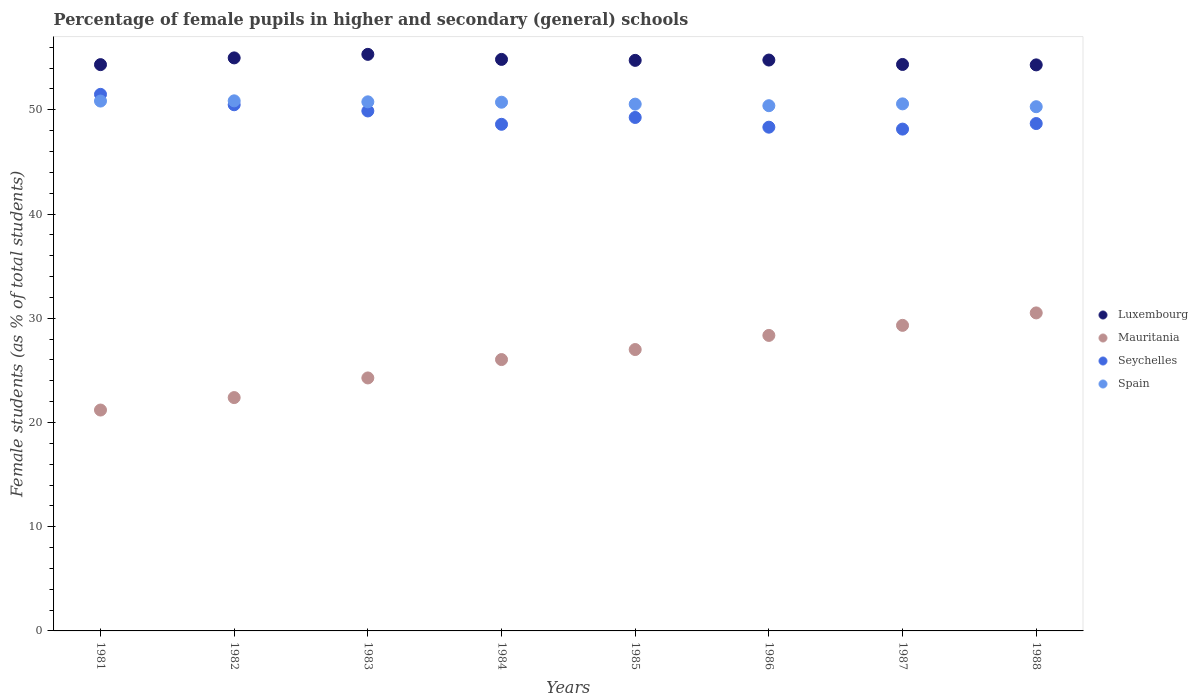What is the percentage of female pupils in higher and secondary schools in Luxembourg in 1983?
Your response must be concise. 55.32. Across all years, what is the maximum percentage of female pupils in higher and secondary schools in Luxembourg?
Provide a short and direct response. 55.32. Across all years, what is the minimum percentage of female pupils in higher and secondary schools in Mauritania?
Provide a succinct answer. 21.19. In which year was the percentage of female pupils in higher and secondary schools in Spain maximum?
Your response must be concise. 1982. In which year was the percentage of female pupils in higher and secondary schools in Mauritania minimum?
Give a very brief answer. 1981. What is the total percentage of female pupils in higher and secondary schools in Mauritania in the graph?
Keep it short and to the point. 209.07. What is the difference between the percentage of female pupils in higher and secondary schools in Luxembourg in 1983 and that in 1984?
Make the answer very short. 0.48. What is the difference between the percentage of female pupils in higher and secondary schools in Luxembourg in 1988 and the percentage of female pupils in higher and secondary schools in Seychelles in 1986?
Keep it short and to the point. 5.98. What is the average percentage of female pupils in higher and secondary schools in Mauritania per year?
Offer a terse response. 26.13. In the year 1987, what is the difference between the percentage of female pupils in higher and secondary schools in Spain and percentage of female pupils in higher and secondary schools in Seychelles?
Ensure brevity in your answer.  2.42. What is the ratio of the percentage of female pupils in higher and secondary schools in Mauritania in 1984 to that in 1987?
Ensure brevity in your answer.  0.89. What is the difference between the highest and the second highest percentage of female pupils in higher and secondary schools in Luxembourg?
Your response must be concise. 0.34. What is the difference between the highest and the lowest percentage of female pupils in higher and secondary schools in Seychelles?
Offer a terse response. 3.33. In how many years, is the percentage of female pupils in higher and secondary schools in Seychelles greater than the average percentage of female pupils in higher and secondary schools in Seychelles taken over all years?
Provide a succinct answer. 3. Is it the case that in every year, the sum of the percentage of female pupils in higher and secondary schools in Spain and percentage of female pupils in higher and secondary schools in Mauritania  is greater than the percentage of female pupils in higher and secondary schools in Luxembourg?
Offer a very short reply. Yes. Does the graph contain grids?
Offer a terse response. No. How many legend labels are there?
Offer a terse response. 4. What is the title of the graph?
Your response must be concise. Percentage of female pupils in higher and secondary (general) schools. Does "Malta" appear as one of the legend labels in the graph?
Make the answer very short. No. What is the label or title of the X-axis?
Make the answer very short. Years. What is the label or title of the Y-axis?
Offer a terse response. Female students (as % of total students). What is the Female students (as % of total students) in Luxembourg in 1981?
Keep it short and to the point. 54.33. What is the Female students (as % of total students) of Mauritania in 1981?
Make the answer very short. 21.19. What is the Female students (as % of total students) in Seychelles in 1981?
Provide a short and direct response. 51.48. What is the Female students (as % of total students) of Spain in 1981?
Offer a terse response. 50.84. What is the Female students (as % of total students) in Luxembourg in 1982?
Make the answer very short. 54.98. What is the Female students (as % of total students) in Mauritania in 1982?
Provide a succinct answer. 22.39. What is the Female students (as % of total students) of Seychelles in 1982?
Make the answer very short. 50.48. What is the Female students (as % of total students) of Spain in 1982?
Offer a very short reply. 50.86. What is the Female students (as % of total students) of Luxembourg in 1983?
Make the answer very short. 55.32. What is the Female students (as % of total students) in Mauritania in 1983?
Provide a short and direct response. 24.27. What is the Female students (as % of total students) in Seychelles in 1983?
Provide a short and direct response. 49.89. What is the Female students (as % of total students) in Spain in 1983?
Provide a short and direct response. 50.76. What is the Female students (as % of total students) in Luxembourg in 1984?
Keep it short and to the point. 54.83. What is the Female students (as % of total students) in Mauritania in 1984?
Offer a very short reply. 26.03. What is the Female students (as % of total students) of Seychelles in 1984?
Provide a succinct answer. 48.61. What is the Female students (as % of total students) of Spain in 1984?
Provide a short and direct response. 50.73. What is the Female students (as % of total students) of Luxembourg in 1985?
Provide a short and direct response. 54.74. What is the Female students (as % of total students) of Mauritania in 1985?
Provide a succinct answer. 27. What is the Female students (as % of total students) of Seychelles in 1985?
Your response must be concise. 49.26. What is the Female students (as % of total students) in Spain in 1985?
Make the answer very short. 50.54. What is the Female students (as % of total students) of Luxembourg in 1986?
Offer a very short reply. 54.77. What is the Female students (as % of total students) in Mauritania in 1986?
Make the answer very short. 28.35. What is the Female students (as % of total students) of Seychelles in 1986?
Your answer should be very brief. 48.33. What is the Female students (as % of total students) in Spain in 1986?
Offer a very short reply. 50.39. What is the Female students (as % of total students) of Luxembourg in 1987?
Your answer should be very brief. 54.35. What is the Female students (as % of total students) in Mauritania in 1987?
Your answer should be very brief. 29.32. What is the Female students (as % of total students) of Seychelles in 1987?
Offer a terse response. 48.15. What is the Female students (as % of total students) in Spain in 1987?
Make the answer very short. 50.57. What is the Female students (as % of total students) in Luxembourg in 1988?
Make the answer very short. 54.31. What is the Female students (as % of total students) in Mauritania in 1988?
Give a very brief answer. 30.51. What is the Female students (as % of total students) in Seychelles in 1988?
Provide a succinct answer. 48.68. What is the Female students (as % of total students) of Spain in 1988?
Make the answer very short. 50.29. Across all years, what is the maximum Female students (as % of total students) of Luxembourg?
Provide a short and direct response. 55.32. Across all years, what is the maximum Female students (as % of total students) in Mauritania?
Your answer should be very brief. 30.51. Across all years, what is the maximum Female students (as % of total students) of Seychelles?
Provide a succinct answer. 51.48. Across all years, what is the maximum Female students (as % of total students) in Spain?
Your response must be concise. 50.86. Across all years, what is the minimum Female students (as % of total students) of Luxembourg?
Your answer should be compact. 54.31. Across all years, what is the minimum Female students (as % of total students) of Mauritania?
Ensure brevity in your answer.  21.19. Across all years, what is the minimum Female students (as % of total students) in Seychelles?
Offer a very short reply. 48.15. Across all years, what is the minimum Female students (as % of total students) in Spain?
Ensure brevity in your answer.  50.29. What is the total Female students (as % of total students) in Luxembourg in the graph?
Make the answer very short. 437.63. What is the total Female students (as % of total students) of Mauritania in the graph?
Give a very brief answer. 209.07. What is the total Female students (as % of total students) in Seychelles in the graph?
Offer a very short reply. 394.88. What is the total Female students (as % of total students) in Spain in the graph?
Offer a terse response. 404.98. What is the difference between the Female students (as % of total students) in Luxembourg in 1981 and that in 1982?
Make the answer very short. -0.65. What is the difference between the Female students (as % of total students) in Mauritania in 1981 and that in 1982?
Offer a very short reply. -1.2. What is the difference between the Female students (as % of total students) of Seychelles in 1981 and that in 1982?
Provide a succinct answer. 1. What is the difference between the Female students (as % of total students) in Spain in 1981 and that in 1982?
Your response must be concise. -0.02. What is the difference between the Female students (as % of total students) in Luxembourg in 1981 and that in 1983?
Your response must be concise. -0.99. What is the difference between the Female students (as % of total students) of Mauritania in 1981 and that in 1983?
Give a very brief answer. -3.08. What is the difference between the Female students (as % of total students) in Seychelles in 1981 and that in 1983?
Offer a terse response. 1.59. What is the difference between the Female students (as % of total students) of Spain in 1981 and that in 1983?
Your response must be concise. 0.07. What is the difference between the Female students (as % of total students) of Luxembourg in 1981 and that in 1984?
Keep it short and to the point. -0.5. What is the difference between the Female students (as % of total students) in Mauritania in 1981 and that in 1984?
Offer a very short reply. -4.84. What is the difference between the Female students (as % of total students) of Seychelles in 1981 and that in 1984?
Offer a very short reply. 2.87. What is the difference between the Female students (as % of total students) in Spain in 1981 and that in 1984?
Offer a terse response. 0.11. What is the difference between the Female students (as % of total students) in Luxembourg in 1981 and that in 1985?
Your response must be concise. -0.41. What is the difference between the Female students (as % of total students) in Mauritania in 1981 and that in 1985?
Your answer should be compact. -5.81. What is the difference between the Female students (as % of total students) of Seychelles in 1981 and that in 1985?
Your response must be concise. 2.22. What is the difference between the Female students (as % of total students) of Spain in 1981 and that in 1985?
Keep it short and to the point. 0.29. What is the difference between the Female students (as % of total students) of Luxembourg in 1981 and that in 1986?
Give a very brief answer. -0.44. What is the difference between the Female students (as % of total students) of Mauritania in 1981 and that in 1986?
Make the answer very short. -7.16. What is the difference between the Female students (as % of total students) in Seychelles in 1981 and that in 1986?
Your answer should be compact. 3.15. What is the difference between the Female students (as % of total students) of Spain in 1981 and that in 1986?
Provide a short and direct response. 0.44. What is the difference between the Female students (as % of total students) in Luxembourg in 1981 and that in 1987?
Give a very brief answer. -0.02. What is the difference between the Female students (as % of total students) in Mauritania in 1981 and that in 1987?
Ensure brevity in your answer.  -8.13. What is the difference between the Female students (as % of total students) in Seychelles in 1981 and that in 1987?
Provide a short and direct response. 3.33. What is the difference between the Female students (as % of total students) in Spain in 1981 and that in 1987?
Provide a succinct answer. 0.27. What is the difference between the Female students (as % of total students) of Luxembourg in 1981 and that in 1988?
Offer a very short reply. 0.02. What is the difference between the Female students (as % of total students) of Mauritania in 1981 and that in 1988?
Give a very brief answer. -9.32. What is the difference between the Female students (as % of total students) in Seychelles in 1981 and that in 1988?
Your response must be concise. 2.8. What is the difference between the Female students (as % of total students) in Spain in 1981 and that in 1988?
Provide a short and direct response. 0.54. What is the difference between the Female students (as % of total students) of Luxembourg in 1982 and that in 1983?
Make the answer very short. -0.34. What is the difference between the Female students (as % of total students) in Mauritania in 1982 and that in 1983?
Ensure brevity in your answer.  -1.88. What is the difference between the Female students (as % of total students) of Seychelles in 1982 and that in 1983?
Make the answer very short. 0.59. What is the difference between the Female students (as % of total students) in Spain in 1982 and that in 1983?
Ensure brevity in your answer.  0.1. What is the difference between the Female students (as % of total students) of Luxembourg in 1982 and that in 1984?
Ensure brevity in your answer.  0.14. What is the difference between the Female students (as % of total students) of Mauritania in 1982 and that in 1984?
Ensure brevity in your answer.  -3.65. What is the difference between the Female students (as % of total students) of Seychelles in 1982 and that in 1984?
Provide a short and direct response. 1.88. What is the difference between the Female students (as % of total students) of Spain in 1982 and that in 1984?
Ensure brevity in your answer.  0.13. What is the difference between the Female students (as % of total students) in Luxembourg in 1982 and that in 1985?
Offer a terse response. 0.24. What is the difference between the Female students (as % of total students) of Mauritania in 1982 and that in 1985?
Provide a short and direct response. -4.61. What is the difference between the Female students (as % of total students) of Seychelles in 1982 and that in 1985?
Keep it short and to the point. 1.22. What is the difference between the Female students (as % of total students) in Spain in 1982 and that in 1985?
Provide a succinct answer. 0.32. What is the difference between the Female students (as % of total students) in Luxembourg in 1982 and that in 1986?
Your response must be concise. 0.2. What is the difference between the Female students (as % of total students) of Mauritania in 1982 and that in 1986?
Offer a very short reply. -5.96. What is the difference between the Female students (as % of total students) in Seychelles in 1982 and that in 1986?
Provide a succinct answer. 2.15. What is the difference between the Female students (as % of total students) of Spain in 1982 and that in 1986?
Ensure brevity in your answer.  0.47. What is the difference between the Female students (as % of total students) in Luxembourg in 1982 and that in 1987?
Your response must be concise. 0.63. What is the difference between the Female students (as % of total students) in Mauritania in 1982 and that in 1987?
Make the answer very short. -6.93. What is the difference between the Female students (as % of total students) of Seychelles in 1982 and that in 1987?
Your answer should be compact. 2.34. What is the difference between the Female students (as % of total students) of Spain in 1982 and that in 1987?
Give a very brief answer. 0.29. What is the difference between the Female students (as % of total students) in Luxembourg in 1982 and that in 1988?
Make the answer very short. 0.67. What is the difference between the Female students (as % of total students) of Mauritania in 1982 and that in 1988?
Make the answer very short. -8.12. What is the difference between the Female students (as % of total students) in Seychelles in 1982 and that in 1988?
Ensure brevity in your answer.  1.8. What is the difference between the Female students (as % of total students) of Spain in 1982 and that in 1988?
Offer a very short reply. 0.56. What is the difference between the Female students (as % of total students) of Luxembourg in 1983 and that in 1984?
Make the answer very short. 0.48. What is the difference between the Female students (as % of total students) in Mauritania in 1983 and that in 1984?
Offer a very short reply. -1.76. What is the difference between the Female students (as % of total students) in Seychelles in 1983 and that in 1984?
Your answer should be very brief. 1.28. What is the difference between the Female students (as % of total students) of Spain in 1983 and that in 1984?
Your response must be concise. 0.04. What is the difference between the Female students (as % of total students) in Luxembourg in 1983 and that in 1985?
Your response must be concise. 0.58. What is the difference between the Female students (as % of total students) of Mauritania in 1983 and that in 1985?
Give a very brief answer. -2.73. What is the difference between the Female students (as % of total students) in Seychelles in 1983 and that in 1985?
Ensure brevity in your answer.  0.62. What is the difference between the Female students (as % of total students) in Spain in 1983 and that in 1985?
Provide a short and direct response. 0.22. What is the difference between the Female students (as % of total students) of Luxembourg in 1983 and that in 1986?
Provide a succinct answer. 0.55. What is the difference between the Female students (as % of total students) of Mauritania in 1983 and that in 1986?
Your answer should be compact. -4.08. What is the difference between the Female students (as % of total students) of Seychelles in 1983 and that in 1986?
Your answer should be compact. 1.56. What is the difference between the Female students (as % of total students) in Spain in 1983 and that in 1986?
Offer a very short reply. 0.37. What is the difference between the Female students (as % of total students) in Mauritania in 1983 and that in 1987?
Your response must be concise. -5.05. What is the difference between the Female students (as % of total students) in Seychelles in 1983 and that in 1987?
Your answer should be very brief. 1.74. What is the difference between the Female students (as % of total students) of Spain in 1983 and that in 1987?
Provide a succinct answer. 0.19. What is the difference between the Female students (as % of total students) in Luxembourg in 1983 and that in 1988?
Provide a short and direct response. 1.01. What is the difference between the Female students (as % of total students) of Mauritania in 1983 and that in 1988?
Keep it short and to the point. -6.24. What is the difference between the Female students (as % of total students) of Seychelles in 1983 and that in 1988?
Your response must be concise. 1.21. What is the difference between the Female students (as % of total students) in Spain in 1983 and that in 1988?
Your answer should be compact. 0.47. What is the difference between the Female students (as % of total students) of Luxembourg in 1984 and that in 1985?
Your answer should be very brief. 0.09. What is the difference between the Female students (as % of total students) in Mauritania in 1984 and that in 1985?
Keep it short and to the point. -0.96. What is the difference between the Female students (as % of total students) in Seychelles in 1984 and that in 1985?
Keep it short and to the point. -0.66. What is the difference between the Female students (as % of total students) in Spain in 1984 and that in 1985?
Offer a terse response. 0.18. What is the difference between the Female students (as % of total students) of Luxembourg in 1984 and that in 1986?
Provide a succinct answer. 0.06. What is the difference between the Female students (as % of total students) in Mauritania in 1984 and that in 1986?
Your answer should be very brief. -2.32. What is the difference between the Female students (as % of total students) of Seychelles in 1984 and that in 1986?
Your answer should be very brief. 0.28. What is the difference between the Female students (as % of total students) of Spain in 1984 and that in 1986?
Make the answer very short. 0.34. What is the difference between the Female students (as % of total students) of Luxembourg in 1984 and that in 1987?
Your answer should be very brief. 0.49. What is the difference between the Female students (as % of total students) in Mauritania in 1984 and that in 1987?
Offer a very short reply. -3.28. What is the difference between the Female students (as % of total students) of Seychelles in 1984 and that in 1987?
Make the answer very short. 0.46. What is the difference between the Female students (as % of total students) of Spain in 1984 and that in 1987?
Provide a short and direct response. 0.16. What is the difference between the Female students (as % of total students) of Luxembourg in 1984 and that in 1988?
Ensure brevity in your answer.  0.53. What is the difference between the Female students (as % of total students) of Mauritania in 1984 and that in 1988?
Provide a short and direct response. -4.48. What is the difference between the Female students (as % of total students) in Seychelles in 1984 and that in 1988?
Provide a short and direct response. -0.07. What is the difference between the Female students (as % of total students) in Spain in 1984 and that in 1988?
Your response must be concise. 0.43. What is the difference between the Female students (as % of total students) in Luxembourg in 1985 and that in 1986?
Provide a short and direct response. -0.03. What is the difference between the Female students (as % of total students) in Mauritania in 1985 and that in 1986?
Keep it short and to the point. -1.35. What is the difference between the Female students (as % of total students) in Seychelles in 1985 and that in 1986?
Provide a succinct answer. 0.93. What is the difference between the Female students (as % of total students) in Spain in 1985 and that in 1986?
Ensure brevity in your answer.  0.15. What is the difference between the Female students (as % of total students) of Luxembourg in 1985 and that in 1987?
Ensure brevity in your answer.  0.39. What is the difference between the Female students (as % of total students) of Mauritania in 1985 and that in 1987?
Keep it short and to the point. -2.32. What is the difference between the Female students (as % of total students) in Seychelles in 1985 and that in 1987?
Offer a very short reply. 1.12. What is the difference between the Female students (as % of total students) in Spain in 1985 and that in 1987?
Offer a very short reply. -0.03. What is the difference between the Female students (as % of total students) in Luxembourg in 1985 and that in 1988?
Provide a short and direct response. 0.43. What is the difference between the Female students (as % of total students) of Mauritania in 1985 and that in 1988?
Your answer should be compact. -3.51. What is the difference between the Female students (as % of total students) of Seychelles in 1985 and that in 1988?
Provide a succinct answer. 0.58. What is the difference between the Female students (as % of total students) in Spain in 1985 and that in 1988?
Ensure brevity in your answer.  0.25. What is the difference between the Female students (as % of total students) in Luxembourg in 1986 and that in 1987?
Your answer should be very brief. 0.42. What is the difference between the Female students (as % of total students) in Mauritania in 1986 and that in 1987?
Provide a succinct answer. -0.97. What is the difference between the Female students (as % of total students) in Seychelles in 1986 and that in 1987?
Provide a succinct answer. 0.18. What is the difference between the Female students (as % of total students) in Spain in 1986 and that in 1987?
Your response must be concise. -0.18. What is the difference between the Female students (as % of total students) of Luxembourg in 1986 and that in 1988?
Offer a terse response. 0.46. What is the difference between the Female students (as % of total students) in Mauritania in 1986 and that in 1988?
Your response must be concise. -2.16. What is the difference between the Female students (as % of total students) in Seychelles in 1986 and that in 1988?
Offer a terse response. -0.35. What is the difference between the Female students (as % of total students) of Spain in 1986 and that in 1988?
Ensure brevity in your answer.  0.1. What is the difference between the Female students (as % of total students) in Luxembourg in 1987 and that in 1988?
Ensure brevity in your answer.  0.04. What is the difference between the Female students (as % of total students) of Mauritania in 1987 and that in 1988?
Your answer should be compact. -1.19. What is the difference between the Female students (as % of total students) of Seychelles in 1987 and that in 1988?
Make the answer very short. -0.53. What is the difference between the Female students (as % of total students) in Spain in 1987 and that in 1988?
Provide a short and direct response. 0.27. What is the difference between the Female students (as % of total students) of Luxembourg in 1981 and the Female students (as % of total students) of Mauritania in 1982?
Offer a terse response. 31.94. What is the difference between the Female students (as % of total students) of Luxembourg in 1981 and the Female students (as % of total students) of Seychelles in 1982?
Ensure brevity in your answer.  3.85. What is the difference between the Female students (as % of total students) in Luxembourg in 1981 and the Female students (as % of total students) in Spain in 1982?
Provide a short and direct response. 3.47. What is the difference between the Female students (as % of total students) in Mauritania in 1981 and the Female students (as % of total students) in Seychelles in 1982?
Your response must be concise. -29.29. What is the difference between the Female students (as % of total students) in Mauritania in 1981 and the Female students (as % of total students) in Spain in 1982?
Keep it short and to the point. -29.67. What is the difference between the Female students (as % of total students) in Seychelles in 1981 and the Female students (as % of total students) in Spain in 1982?
Your answer should be compact. 0.62. What is the difference between the Female students (as % of total students) of Luxembourg in 1981 and the Female students (as % of total students) of Mauritania in 1983?
Your answer should be compact. 30.06. What is the difference between the Female students (as % of total students) of Luxembourg in 1981 and the Female students (as % of total students) of Seychelles in 1983?
Keep it short and to the point. 4.44. What is the difference between the Female students (as % of total students) in Luxembourg in 1981 and the Female students (as % of total students) in Spain in 1983?
Your response must be concise. 3.57. What is the difference between the Female students (as % of total students) of Mauritania in 1981 and the Female students (as % of total students) of Seychelles in 1983?
Provide a short and direct response. -28.7. What is the difference between the Female students (as % of total students) of Mauritania in 1981 and the Female students (as % of total students) of Spain in 1983?
Offer a terse response. -29.57. What is the difference between the Female students (as % of total students) of Seychelles in 1981 and the Female students (as % of total students) of Spain in 1983?
Ensure brevity in your answer.  0.72. What is the difference between the Female students (as % of total students) of Luxembourg in 1981 and the Female students (as % of total students) of Mauritania in 1984?
Provide a short and direct response. 28.3. What is the difference between the Female students (as % of total students) in Luxembourg in 1981 and the Female students (as % of total students) in Seychelles in 1984?
Provide a succinct answer. 5.72. What is the difference between the Female students (as % of total students) in Luxembourg in 1981 and the Female students (as % of total students) in Spain in 1984?
Your answer should be very brief. 3.61. What is the difference between the Female students (as % of total students) of Mauritania in 1981 and the Female students (as % of total students) of Seychelles in 1984?
Keep it short and to the point. -27.42. What is the difference between the Female students (as % of total students) of Mauritania in 1981 and the Female students (as % of total students) of Spain in 1984?
Your response must be concise. -29.53. What is the difference between the Female students (as % of total students) of Seychelles in 1981 and the Female students (as % of total students) of Spain in 1984?
Give a very brief answer. 0.75. What is the difference between the Female students (as % of total students) in Luxembourg in 1981 and the Female students (as % of total students) in Mauritania in 1985?
Make the answer very short. 27.33. What is the difference between the Female students (as % of total students) in Luxembourg in 1981 and the Female students (as % of total students) in Seychelles in 1985?
Offer a very short reply. 5.07. What is the difference between the Female students (as % of total students) of Luxembourg in 1981 and the Female students (as % of total students) of Spain in 1985?
Ensure brevity in your answer.  3.79. What is the difference between the Female students (as % of total students) of Mauritania in 1981 and the Female students (as % of total students) of Seychelles in 1985?
Provide a succinct answer. -28.07. What is the difference between the Female students (as % of total students) of Mauritania in 1981 and the Female students (as % of total students) of Spain in 1985?
Make the answer very short. -29.35. What is the difference between the Female students (as % of total students) of Seychelles in 1981 and the Female students (as % of total students) of Spain in 1985?
Make the answer very short. 0.94. What is the difference between the Female students (as % of total students) of Luxembourg in 1981 and the Female students (as % of total students) of Mauritania in 1986?
Give a very brief answer. 25.98. What is the difference between the Female students (as % of total students) in Luxembourg in 1981 and the Female students (as % of total students) in Seychelles in 1986?
Your response must be concise. 6. What is the difference between the Female students (as % of total students) of Luxembourg in 1981 and the Female students (as % of total students) of Spain in 1986?
Your answer should be very brief. 3.94. What is the difference between the Female students (as % of total students) of Mauritania in 1981 and the Female students (as % of total students) of Seychelles in 1986?
Your answer should be very brief. -27.14. What is the difference between the Female students (as % of total students) of Mauritania in 1981 and the Female students (as % of total students) of Spain in 1986?
Your answer should be very brief. -29.2. What is the difference between the Female students (as % of total students) of Seychelles in 1981 and the Female students (as % of total students) of Spain in 1986?
Give a very brief answer. 1.09. What is the difference between the Female students (as % of total students) of Luxembourg in 1981 and the Female students (as % of total students) of Mauritania in 1987?
Ensure brevity in your answer.  25.01. What is the difference between the Female students (as % of total students) of Luxembourg in 1981 and the Female students (as % of total students) of Seychelles in 1987?
Your answer should be compact. 6.19. What is the difference between the Female students (as % of total students) in Luxembourg in 1981 and the Female students (as % of total students) in Spain in 1987?
Make the answer very short. 3.76. What is the difference between the Female students (as % of total students) of Mauritania in 1981 and the Female students (as % of total students) of Seychelles in 1987?
Your answer should be very brief. -26.95. What is the difference between the Female students (as % of total students) in Mauritania in 1981 and the Female students (as % of total students) in Spain in 1987?
Make the answer very short. -29.38. What is the difference between the Female students (as % of total students) of Seychelles in 1981 and the Female students (as % of total students) of Spain in 1987?
Your answer should be very brief. 0.91. What is the difference between the Female students (as % of total students) of Luxembourg in 1981 and the Female students (as % of total students) of Mauritania in 1988?
Offer a terse response. 23.82. What is the difference between the Female students (as % of total students) in Luxembourg in 1981 and the Female students (as % of total students) in Seychelles in 1988?
Your answer should be compact. 5.65. What is the difference between the Female students (as % of total students) of Luxembourg in 1981 and the Female students (as % of total students) of Spain in 1988?
Keep it short and to the point. 4.04. What is the difference between the Female students (as % of total students) of Mauritania in 1981 and the Female students (as % of total students) of Seychelles in 1988?
Your response must be concise. -27.49. What is the difference between the Female students (as % of total students) of Mauritania in 1981 and the Female students (as % of total students) of Spain in 1988?
Provide a succinct answer. -29.1. What is the difference between the Female students (as % of total students) of Seychelles in 1981 and the Female students (as % of total students) of Spain in 1988?
Your response must be concise. 1.18. What is the difference between the Female students (as % of total students) of Luxembourg in 1982 and the Female students (as % of total students) of Mauritania in 1983?
Offer a terse response. 30.71. What is the difference between the Female students (as % of total students) in Luxembourg in 1982 and the Female students (as % of total students) in Seychelles in 1983?
Your response must be concise. 5.09. What is the difference between the Female students (as % of total students) of Luxembourg in 1982 and the Female students (as % of total students) of Spain in 1983?
Your response must be concise. 4.22. What is the difference between the Female students (as % of total students) of Mauritania in 1982 and the Female students (as % of total students) of Seychelles in 1983?
Offer a very short reply. -27.5. What is the difference between the Female students (as % of total students) of Mauritania in 1982 and the Female students (as % of total students) of Spain in 1983?
Offer a terse response. -28.38. What is the difference between the Female students (as % of total students) in Seychelles in 1982 and the Female students (as % of total students) in Spain in 1983?
Make the answer very short. -0.28. What is the difference between the Female students (as % of total students) in Luxembourg in 1982 and the Female students (as % of total students) in Mauritania in 1984?
Ensure brevity in your answer.  28.94. What is the difference between the Female students (as % of total students) of Luxembourg in 1982 and the Female students (as % of total students) of Seychelles in 1984?
Offer a terse response. 6.37. What is the difference between the Female students (as % of total students) in Luxembourg in 1982 and the Female students (as % of total students) in Spain in 1984?
Offer a very short reply. 4.25. What is the difference between the Female students (as % of total students) of Mauritania in 1982 and the Female students (as % of total students) of Seychelles in 1984?
Offer a very short reply. -26.22. What is the difference between the Female students (as % of total students) of Mauritania in 1982 and the Female students (as % of total students) of Spain in 1984?
Offer a very short reply. -28.34. What is the difference between the Female students (as % of total students) in Seychelles in 1982 and the Female students (as % of total students) in Spain in 1984?
Your response must be concise. -0.24. What is the difference between the Female students (as % of total students) in Luxembourg in 1982 and the Female students (as % of total students) in Mauritania in 1985?
Ensure brevity in your answer.  27.98. What is the difference between the Female students (as % of total students) in Luxembourg in 1982 and the Female students (as % of total students) in Seychelles in 1985?
Your response must be concise. 5.71. What is the difference between the Female students (as % of total students) in Luxembourg in 1982 and the Female students (as % of total students) in Spain in 1985?
Your response must be concise. 4.43. What is the difference between the Female students (as % of total students) in Mauritania in 1982 and the Female students (as % of total students) in Seychelles in 1985?
Give a very brief answer. -26.88. What is the difference between the Female students (as % of total students) of Mauritania in 1982 and the Female students (as % of total students) of Spain in 1985?
Your response must be concise. -28.16. What is the difference between the Female students (as % of total students) of Seychelles in 1982 and the Female students (as % of total students) of Spain in 1985?
Your answer should be very brief. -0.06. What is the difference between the Female students (as % of total students) in Luxembourg in 1982 and the Female students (as % of total students) in Mauritania in 1986?
Keep it short and to the point. 26.63. What is the difference between the Female students (as % of total students) of Luxembourg in 1982 and the Female students (as % of total students) of Seychelles in 1986?
Make the answer very short. 6.65. What is the difference between the Female students (as % of total students) in Luxembourg in 1982 and the Female students (as % of total students) in Spain in 1986?
Your answer should be compact. 4.59. What is the difference between the Female students (as % of total students) in Mauritania in 1982 and the Female students (as % of total students) in Seychelles in 1986?
Keep it short and to the point. -25.94. What is the difference between the Female students (as % of total students) in Mauritania in 1982 and the Female students (as % of total students) in Spain in 1986?
Your response must be concise. -28. What is the difference between the Female students (as % of total students) of Seychelles in 1982 and the Female students (as % of total students) of Spain in 1986?
Provide a short and direct response. 0.09. What is the difference between the Female students (as % of total students) in Luxembourg in 1982 and the Female students (as % of total students) in Mauritania in 1987?
Provide a succinct answer. 25.66. What is the difference between the Female students (as % of total students) in Luxembourg in 1982 and the Female students (as % of total students) in Seychelles in 1987?
Your response must be concise. 6.83. What is the difference between the Female students (as % of total students) in Luxembourg in 1982 and the Female students (as % of total students) in Spain in 1987?
Give a very brief answer. 4.41. What is the difference between the Female students (as % of total students) in Mauritania in 1982 and the Female students (as % of total students) in Seychelles in 1987?
Give a very brief answer. -25.76. What is the difference between the Female students (as % of total students) in Mauritania in 1982 and the Female students (as % of total students) in Spain in 1987?
Provide a short and direct response. -28.18. What is the difference between the Female students (as % of total students) of Seychelles in 1982 and the Female students (as % of total students) of Spain in 1987?
Give a very brief answer. -0.09. What is the difference between the Female students (as % of total students) in Luxembourg in 1982 and the Female students (as % of total students) in Mauritania in 1988?
Your answer should be very brief. 24.47. What is the difference between the Female students (as % of total students) in Luxembourg in 1982 and the Female students (as % of total students) in Seychelles in 1988?
Provide a short and direct response. 6.3. What is the difference between the Female students (as % of total students) of Luxembourg in 1982 and the Female students (as % of total students) of Spain in 1988?
Offer a terse response. 4.68. What is the difference between the Female students (as % of total students) in Mauritania in 1982 and the Female students (as % of total students) in Seychelles in 1988?
Your response must be concise. -26.29. What is the difference between the Female students (as % of total students) of Mauritania in 1982 and the Female students (as % of total students) of Spain in 1988?
Make the answer very short. -27.91. What is the difference between the Female students (as % of total students) in Seychelles in 1982 and the Female students (as % of total students) in Spain in 1988?
Make the answer very short. 0.19. What is the difference between the Female students (as % of total students) in Luxembourg in 1983 and the Female students (as % of total students) in Mauritania in 1984?
Make the answer very short. 29.28. What is the difference between the Female students (as % of total students) in Luxembourg in 1983 and the Female students (as % of total students) in Seychelles in 1984?
Your answer should be compact. 6.71. What is the difference between the Female students (as % of total students) of Luxembourg in 1983 and the Female students (as % of total students) of Spain in 1984?
Your answer should be very brief. 4.59. What is the difference between the Female students (as % of total students) in Mauritania in 1983 and the Female students (as % of total students) in Seychelles in 1984?
Provide a short and direct response. -24.34. What is the difference between the Female students (as % of total students) in Mauritania in 1983 and the Female students (as % of total students) in Spain in 1984?
Your answer should be very brief. -26.45. What is the difference between the Female students (as % of total students) in Seychelles in 1983 and the Female students (as % of total students) in Spain in 1984?
Make the answer very short. -0.84. What is the difference between the Female students (as % of total students) of Luxembourg in 1983 and the Female students (as % of total students) of Mauritania in 1985?
Your answer should be compact. 28.32. What is the difference between the Female students (as % of total students) in Luxembourg in 1983 and the Female students (as % of total students) in Seychelles in 1985?
Make the answer very short. 6.05. What is the difference between the Female students (as % of total students) in Luxembourg in 1983 and the Female students (as % of total students) in Spain in 1985?
Offer a very short reply. 4.78. What is the difference between the Female students (as % of total students) in Mauritania in 1983 and the Female students (as % of total students) in Seychelles in 1985?
Your answer should be compact. -24.99. What is the difference between the Female students (as % of total students) of Mauritania in 1983 and the Female students (as % of total students) of Spain in 1985?
Your answer should be compact. -26.27. What is the difference between the Female students (as % of total students) of Seychelles in 1983 and the Female students (as % of total students) of Spain in 1985?
Ensure brevity in your answer.  -0.66. What is the difference between the Female students (as % of total students) of Luxembourg in 1983 and the Female students (as % of total students) of Mauritania in 1986?
Ensure brevity in your answer.  26.97. What is the difference between the Female students (as % of total students) in Luxembourg in 1983 and the Female students (as % of total students) in Seychelles in 1986?
Offer a very short reply. 6.99. What is the difference between the Female students (as % of total students) in Luxembourg in 1983 and the Female students (as % of total students) in Spain in 1986?
Give a very brief answer. 4.93. What is the difference between the Female students (as % of total students) in Mauritania in 1983 and the Female students (as % of total students) in Seychelles in 1986?
Provide a succinct answer. -24.06. What is the difference between the Female students (as % of total students) of Mauritania in 1983 and the Female students (as % of total students) of Spain in 1986?
Your answer should be very brief. -26.12. What is the difference between the Female students (as % of total students) in Seychelles in 1983 and the Female students (as % of total students) in Spain in 1986?
Ensure brevity in your answer.  -0.5. What is the difference between the Female students (as % of total students) of Luxembourg in 1983 and the Female students (as % of total students) of Mauritania in 1987?
Keep it short and to the point. 26. What is the difference between the Female students (as % of total students) in Luxembourg in 1983 and the Female students (as % of total students) in Seychelles in 1987?
Offer a terse response. 7.17. What is the difference between the Female students (as % of total students) in Luxembourg in 1983 and the Female students (as % of total students) in Spain in 1987?
Offer a terse response. 4.75. What is the difference between the Female students (as % of total students) in Mauritania in 1983 and the Female students (as % of total students) in Seychelles in 1987?
Your answer should be very brief. -23.87. What is the difference between the Female students (as % of total students) in Mauritania in 1983 and the Female students (as % of total students) in Spain in 1987?
Keep it short and to the point. -26.3. What is the difference between the Female students (as % of total students) in Seychelles in 1983 and the Female students (as % of total students) in Spain in 1987?
Keep it short and to the point. -0.68. What is the difference between the Female students (as % of total students) in Luxembourg in 1983 and the Female students (as % of total students) in Mauritania in 1988?
Provide a succinct answer. 24.81. What is the difference between the Female students (as % of total students) of Luxembourg in 1983 and the Female students (as % of total students) of Seychelles in 1988?
Provide a short and direct response. 6.64. What is the difference between the Female students (as % of total students) in Luxembourg in 1983 and the Female students (as % of total students) in Spain in 1988?
Offer a terse response. 5.02. What is the difference between the Female students (as % of total students) of Mauritania in 1983 and the Female students (as % of total students) of Seychelles in 1988?
Give a very brief answer. -24.41. What is the difference between the Female students (as % of total students) of Mauritania in 1983 and the Female students (as % of total students) of Spain in 1988?
Your response must be concise. -26.02. What is the difference between the Female students (as % of total students) of Seychelles in 1983 and the Female students (as % of total students) of Spain in 1988?
Offer a very short reply. -0.41. What is the difference between the Female students (as % of total students) in Luxembourg in 1984 and the Female students (as % of total students) in Mauritania in 1985?
Ensure brevity in your answer.  27.84. What is the difference between the Female students (as % of total students) in Luxembourg in 1984 and the Female students (as % of total students) in Seychelles in 1985?
Provide a short and direct response. 5.57. What is the difference between the Female students (as % of total students) of Luxembourg in 1984 and the Female students (as % of total students) of Spain in 1985?
Provide a short and direct response. 4.29. What is the difference between the Female students (as % of total students) in Mauritania in 1984 and the Female students (as % of total students) in Seychelles in 1985?
Provide a succinct answer. -23.23. What is the difference between the Female students (as % of total students) in Mauritania in 1984 and the Female students (as % of total students) in Spain in 1985?
Your answer should be very brief. -24.51. What is the difference between the Female students (as % of total students) of Seychelles in 1984 and the Female students (as % of total students) of Spain in 1985?
Provide a succinct answer. -1.94. What is the difference between the Female students (as % of total students) in Luxembourg in 1984 and the Female students (as % of total students) in Mauritania in 1986?
Give a very brief answer. 26.48. What is the difference between the Female students (as % of total students) of Luxembourg in 1984 and the Female students (as % of total students) of Seychelles in 1986?
Your response must be concise. 6.5. What is the difference between the Female students (as % of total students) of Luxembourg in 1984 and the Female students (as % of total students) of Spain in 1986?
Offer a terse response. 4.44. What is the difference between the Female students (as % of total students) in Mauritania in 1984 and the Female students (as % of total students) in Seychelles in 1986?
Offer a very short reply. -22.3. What is the difference between the Female students (as % of total students) of Mauritania in 1984 and the Female students (as % of total students) of Spain in 1986?
Your answer should be compact. -24.36. What is the difference between the Female students (as % of total students) of Seychelles in 1984 and the Female students (as % of total students) of Spain in 1986?
Keep it short and to the point. -1.78. What is the difference between the Female students (as % of total students) of Luxembourg in 1984 and the Female students (as % of total students) of Mauritania in 1987?
Give a very brief answer. 25.52. What is the difference between the Female students (as % of total students) of Luxembourg in 1984 and the Female students (as % of total students) of Seychelles in 1987?
Offer a very short reply. 6.69. What is the difference between the Female students (as % of total students) in Luxembourg in 1984 and the Female students (as % of total students) in Spain in 1987?
Make the answer very short. 4.27. What is the difference between the Female students (as % of total students) in Mauritania in 1984 and the Female students (as % of total students) in Seychelles in 1987?
Keep it short and to the point. -22.11. What is the difference between the Female students (as % of total students) in Mauritania in 1984 and the Female students (as % of total students) in Spain in 1987?
Your answer should be very brief. -24.53. What is the difference between the Female students (as % of total students) of Seychelles in 1984 and the Female students (as % of total students) of Spain in 1987?
Keep it short and to the point. -1.96. What is the difference between the Female students (as % of total students) in Luxembourg in 1984 and the Female students (as % of total students) in Mauritania in 1988?
Your answer should be very brief. 24.32. What is the difference between the Female students (as % of total students) of Luxembourg in 1984 and the Female students (as % of total students) of Seychelles in 1988?
Ensure brevity in your answer.  6.15. What is the difference between the Female students (as % of total students) in Luxembourg in 1984 and the Female students (as % of total students) in Spain in 1988?
Ensure brevity in your answer.  4.54. What is the difference between the Female students (as % of total students) in Mauritania in 1984 and the Female students (as % of total students) in Seychelles in 1988?
Provide a succinct answer. -22.65. What is the difference between the Female students (as % of total students) of Mauritania in 1984 and the Female students (as % of total students) of Spain in 1988?
Provide a succinct answer. -24.26. What is the difference between the Female students (as % of total students) of Seychelles in 1984 and the Female students (as % of total students) of Spain in 1988?
Provide a succinct answer. -1.69. What is the difference between the Female students (as % of total students) of Luxembourg in 1985 and the Female students (as % of total students) of Mauritania in 1986?
Provide a short and direct response. 26.39. What is the difference between the Female students (as % of total students) of Luxembourg in 1985 and the Female students (as % of total students) of Seychelles in 1986?
Keep it short and to the point. 6.41. What is the difference between the Female students (as % of total students) of Luxembourg in 1985 and the Female students (as % of total students) of Spain in 1986?
Make the answer very short. 4.35. What is the difference between the Female students (as % of total students) in Mauritania in 1985 and the Female students (as % of total students) in Seychelles in 1986?
Your answer should be compact. -21.33. What is the difference between the Female students (as % of total students) of Mauritania in 1985 and the Female students (as % of total students) of Spain in 1986?
Your answer should be very brief. -23.39. What is the difference between the Female students (as % of total students) of Seychelles in 1985 and the Female students (as % of total students) of Spain in 1986?
Offer a terse response. -1.13. What is the difference between the Female students (as % of total students) of Luxembourg in 1985 and the Female students (as % of total students) of Mauritania in 1987?
Provide a succinct answer. 25.42. What is the difference between the Female students (as % of total students) of Luxembourg in 1985 and the Female students (as % of total students) of Seychelles in 1987?
Make the answer very short. 6.59. What is the difference between the Female students (as % of total students) of Luxembourg in 1985 and the Female students (as % of total students) of Spain in 1987?
Offer a terse response. 4.17. What is the difference between the Female students (as % of total students) of Mauritania in 1985 and the Female students (as % of total students) of Seychelles in 1987?
Offer a terse response. -21.15. What is the difference between the Female students (as % of total students) in Mauritania in 1985 and the Female students (as % of total students) in Spain in 1987?
Your answer should be very brief. -23.57. What is the difference between the Female students (as % of total students) in Seychelles in 1985 and the Female students (as % of total students) in Spain in 1987?
Ensure brevity in your answer.  -1.31. What is the difference between the Female students (as % of total students) of Luxembourg in 1985 and the Female students (as % of total students) of Mauritania in 1988?
Keep it short and to the point. 24.23. What is the difference between the Female students (as % of total students) of Luxembourg in 1985 and the Female students (as % of total students) of Seychelles in 1988?
Ensure brevity in your answer.  6.06. What is the difference between the Female students (as % of total students) in Luxembourg in 1985 and the Female students (as % of total students) in Spain in 1988?
Your answer should be compact. 4.45. What is the difference between the Female students (as % of total students) of Mauritania in 1985 and the Female students (as % of total students) of Seychelles in 1988?
Keep it short and to the point. -21.68. What is the difference between the Female students (as % of total students) in Mauritania in 1985 and the Female students (as % of total students) in Spain in 1988?
Your response must be concise. -23.3. What is the difference between the Female students (as % of total students) in Seychelles in 1985 and the Female students (as % of total students) in Spain in 1988?
Ensure brevity in your answer.  -1.03. What is the difference between the Female students (as % of total students) in Luxembourg in 1986 and the Female students (as % of total students) in Mauritania in 1987?
Keep it short and to the point. 25.46. What is the difference between the Female students (as % of total students) in Luxembourg in 1986 and the Female students (as % of total students) in Seychelles in 1987?
Your response must be concise. 6.63. What is the difference between the Female students (as % of total students) in Luxembourg in 1986 and the Female students (as % of total students) in Spain in 1987?
Provide a succinct answer. 4.2. What is the difference between the Female students (as % of total students) of Mauritania in 1986 and the Female students (as % of total students) of Seychelles in 1987?
Your answer should be very brief. -19.8. What is the difference between the Female students (as % of total students) in Mauritania in 1986 and the Female students (as % of total students) in Spain in 1987?
Your response must be concise. -22.22. What is the difference between the Female students (as % of total students) of Seychelles in 1986 and the Female students (as % of total students) of Spain in 1987?
Provide a succinct answer. -2.24. What is the difference between the Female students (as % of total students) of Luxembourg in 1986 and the Female students (as % of total students) of Mauritania in 1988?
Give a very brief answer. 24.26. What is the difference between the Female students (as % of total students) of Luxembourg in 1986 and the Female students (as % of total students) of Seychelles in 1988?
Provide a short and direct response. 6.09. What is the difference between the Female students (as % of total students) in Luxembourg in 1986 and the Female students (as % of total students) in Spain in 1988?
Your answer should be compact. 4.48. What is the difference between the Female students (as % of total students) of Mauritania in 1986 and the Female students (as % of total students) of Seychelles in 1988?
Your response must be concise. -20.33. What is the difference between the Female students (as % of total students) in Mauritania in 1986 and the Female students (as % of total students) in Spain in 1988?
Give a very brief answer. -21.94. What is the difference between the Female students (as % of total students) of Seychelles in 1986 and the Female students (as % of total students) of Spain in 1988?
Provide a succinct answer. -1.96. What is the difference between the Female students (as % of total students) in Luxembourg in 1987 and the Female students (as % of total students) in Mauritania in 1988?
Offer a very short reply. 23.84. What is the difference between the Female students (as % of total students) in Luxembourg in 1987 and the Female students (as % of total students) in Seychelles in 1988?
Provide a short and direct response. 5.67. What is the difference between the Female students (as % of total students) in Luxembourg in 1987 and the Female students (as % of total students) in Spain in 1988?
Your answer should be very brief. 4.05. What is the difference between the Female students (as % of total students) in Mauritania in 1987 and the Female students (as % of total students) in Seychelles in 1988?
Your response must be concise. -19.36. What is the difference between the Female students (as % of total students) of Mauritania in 1987 and the Female students (as % of total students) of Spain in 1988?
Make the answer very short. -20.98. What is the difference between the Female students (as % of total students) in Seychelles in 1987 and the Female students (as % of total students) in Spain in 1988?
Make the answer very short. -2.15. What is the average Female students (as % of total students) in Luxembourg per year?
Provide a succinct answer. 54.7. What is the average Female students (as % of total students) in Mauritania per year?
Offer a very short reply. 26.13. What is the average Female students (as % of total students) in Seychelles per year?
Your answer should be compact. 49.36. What is the average Female students (as % of total students) in Spain per year?
Offer a terse response. 50.62. In the year 1981, what is the difference between the Female students (as % of total students) in Luxembourg and Female students (as % of total students) in Mauritania?
Ensure brevity in your answer.  33.14. In the year 1981, what is the difference between the Female students (as % of total students) in Luxembourg and Female students (as % of total students) in Seychelles?
Your response must be concise. 2.85. In the year 1981, what is the difference between the Female students (as % of total students) of Luxembourg and Female students (as % of total students) of Spain?
Keep it short and to the point. 3.5. In the year 1981, what is the difference between the Female students (as % of total students) of Mauritania and Female students (as % of total students) of Seychelles?
Keep it short and to the point. -30.29. In the year 1981, what is the difference between the Female students (as % of total students) in Mauritania and Female students (as % of total students) in Spain?
Your response must be concise. -29.64. In the year 1981, what is the difference between the Female students (as % of total students) in Seychelles and Female students (as % of total students) in Spain?
Ensure brevity in your answer.  0.64. In the year 1982, what is the difference between the Female students (as % of total students) in Luxembourg and Female students (as % of total students) in Mauritania?
Give a very brief answer. 32.59. In the year 1982, what is the difference between the Female students (as % of total students) in Luxembourg and Female students (as % of total students) in Seychelles?
Ensure brevity in your answer.  4.49. In the year 1982, what is the difference between the Female students (as % of total students) in Luxembourg and Female students (as % of total students) in Spain?
Provide a succinct answer. 4.12. In the year 1982, what is the difference between the Female students (as % of total students) of Mauritania and Female students (as % of total students) of Seychelles?
Your answer should be very brief. -28.1. In the year 1982, what is the difference between the Female students (as % of total students) of Mauritania and Female students (as % of total students) of Spain?
Provide a succinct answer. -28.47. In the year 1982, what is the difference between the Female students (as % of total students) of Seychelles and Female students (as % of total students) of Spain?
Make the answer very short. -0.38. In the year 1983, what is the difference between the Female students (as % of total students) of Luxembourg and Female students (as % of total students) of Mauritania?
Offer a terse response. 31.05. In the year 1983, what is the difference between the Female students (as % of total students) of Luxembourg and Female students (as % of total students) of Seychelles?
Give a very brief answer. 5.43. In the year 1983, what is the difference between the Female students (as % of total students) in Luxembourg and Female students (as % of total students) in Spain?
Provide a short and direct response. 4.56. In the year 1983, what is the difference between the Female students (as % of total students) of Mauritania and Female students (as % of total students) of Seychelles?
Your answer should be very brief. -25.62. In the year 1983, what is the difference between the Female students (as % of total students) in Mauritania and Female students (as % of total students) in Spain?
Your response must be concise. -26.49. In the year 1983, what is the difference between the Female students (as % of total students) of Seychelles and Female students (as % of total students) of Spain?
Offer a very short reply. -0.87. In the year 1984, what is the difference between the Female students (as % of total students) in Luxembourg and Female students (as % of total students) in Mauritania?
Your response must be concise. 28.8. In the year 1984, what is the difference between the Female students (as % of total students) of Luxembourg and Female students (as % of total students) of Seychelles?
Your answer should be compact. 6.23. In the year 1984, what is the difference between the Female students (as % of total students) of Luxembourg and Female students (as % of total students) of Spain?
Your answer should be very brief. 4.11. In the year 1984, what is the difference between the Female students (as % of total students) of Mauritania and Female students (as % of total students) of Seychelles?
Provide a short and direct response. -22.57. In the year 1984, what is the difference between the Female students (as % of total students) in Mauritania and Female students (as % of total students) in Spain?
Provide a succinct answer. -24.69. In the year 1984, what is the difference between the Female students (as % of total students) in Seychelles and Female students (as % of total students) in Spain?
Offer a very short reply. -2.12. In the year 1985, what is the difference between the Female students (as % of total students) of Luxembourg and Female students (as % of total students) of Mauritania?
Your response must be concise. 27.74. In the year 1985, what is the difference between the Female students (as % of total students) of Luxembourg and Female students (as % of total students) of Seychelles?
Your answer should be compact. 5.48. In the year 1985, what is the difference between the Female students (as % of total students) in Luxembourg and Female students (as % of total students) in Spain?
Your answer should be very brief. 4.2. In the year 1985, what is the difference between the Female students (as % of total students) in Mauritania and Female students (as % of total students) in Seychelles?
Your response must be concise. -22.27. In the year 1985, what is the difference between the Female students (as % of total students) in Mauritania and Female students (as % of total students) in Spain?
Offer a terse response. -23.55. In the year 1985, what is the difference between the Female students (as % of total students) in Seychelles and Female students (as % of total students) in Spain?
Make the answer very short. -1.28. In the year 1986, what is the difference between the Female students (as % of total students) of Luxembourg and Female students (as % of total students) of Mauritania?
Provide a short and direct response. 26.42. In the year 1986, what is the difference between the Female students (as % of total students) in Luxembourg and Female students (as % of total students) in Seychelles?
Offer a terse response. 6.44. In the year 1986, what is the difference between the Female students (as % of total students) of Luxembourg and Female students (as % of total students) of Spain?
Ensure brevity in your answer.  4.38. In the year 1986, what is the difference between the Female students (as % of total students) in Mauritania and Female students (as % of total students) in Seychelles?
Provide a short and direct response. -19.98. In the year 1986, what is the difference between the Female students (as % of total students) in Mauritania and Female students (as % of total students) in Spain?
Offer a terse response. -22.04. In the year 1986, what is the difference between the Female students (as % of total students) in Seychelles and Female students (as % of total students) in Spain?
Ensure brevity in your answer.  -2.06. In the year 1987, what is the difference between the Female students (as % of total students) of Luxembourg and Female students (as % of total students) of Mauritania?
Provide a short and direct response. 25.03. In the year 1987, what is the difference between the Female students (as % of total students) of Luxembourg and Female students (as % of total students) of Seychelles?
Your answer should be very brief. 6.2. In the year 1987, what is the difference between the Female students (as % of total students) of Luxembourg and Female students (as % of total students) of Spain?
Keep it short and to the point. 3.78. In the year 1987, what is the difference between the Female students (as % of total students) of Mauritania and Female students (as % of total students) of Seychelles?
Offer a terse response. -18.83. In the year 1987, what is the difference between the Female students (as % of total students) of Mauritania and Female students (as % of total students) of Spain?
Make the answer very short. -21.25. In the year 1987, what is the difference between the Female students (as % of total students) in Seychelles and Female students (as % of total students) in Spain?
Make the answer very short. -2.42. In the year 1988, what is the difference between the Female students (as % of total students) of Luxembourg and Female students (as % of total students) of Mauritania?
Offer a very short reply. 23.8. In the year 1988, what is the difference between the Female students (as % of total students) in Luxembourg and Female students (as % of total students) in Seychelles?
Make the answer very short. 5.63. In the year 1988, what is the difference between the Female students (as % of total students) of Luxembourg and Female students (as % of total students) of Spain?
Offer a very short reply. 4.01. In the year 1988, what is the difference between the Female students (as % of total students) in Mauritania and Female students (as % of total students) in Seychelles?
Provide a succinct answer. -18.17. In the year 1988, what is the difference between the Female students (as % of total students) of Mauritania and Female students (as % of total students) of Spain?
Your answer should be compact. -19.78. In the year 1988, what is the difference between the Female students (as % of total students) of Seychelles and Female students (as % of total students) of Spain?
Provide a short and direct response. -1.61. What is the ratio of the Female students (as % of total students) in Luxembourg in 1981 to that in 1982?
Provide a short and direct response. 0.99. What is the ratio of the Female students (as % of total students) of Mauritania in 1981 to that in 1982?
Your response must be concise. 0.95. What is the ratio of the Female students (as % of total students) of Seychelles in 1981 to that in 1982?
Offer a very short reply. 1.02. What is the ratio of the Female students (as % of total students) of Luxembourg in 1981 to that in 1983?
Keep it short and to the point. 0.98. What is the ratio of the Female students (as % of total students) in Mauritania in 1981 to that in 1983?
Offer a very short reply. 0.87. What is the ratio of the Female students (as % of total students) of Seychelles in 1981 to that in 1983?
Provide a succinct answer. 1.03. What is the ratio of the Female students (as % of total students) in Spain in 1981 to that in 1983?
Offer a very short reply. 1. What is the ratio of the Female students (as % of total students) of Luxembourg in 1981 to that in 1984?
Provide a short and direct response. 0.99. What is the ratio of the Female students (as % of total students) of Mauritania in 1981 to that in 1984?
Offer a very short reply. 0.81. What is the ratio of the Female students (as % of total students) in Seychelles in 1981 to that in 1984?
Provide a succinct answer. 1.06. What is the ratio of the Female students (as % of total students) in Mauritania in 1981 to that in 1985?
Offer a terse response. 0.79. What is the ratio of the Female students (as % of total students) of Seychelles in 1981 to that in 1985?
Give a very brief answer. 1.04. What is the ratio of the Female students (as % of total students) in Spain in 1981 to that in 1985?
Provide a succinct answer. 1.01. What is the ratio of the Female students (as % of total students) in Luxembourg in 1981 to that in 1986?
Your answer should be compact. 0.99. What is the ratio of the Female students (as % of total students) in Mauritania in 1981 to that in 1986?
Your answer should be compact. 0.75. What is the ratio of the Female students (as % of total students) in Seychelles in 1981 to that in 1986?
Offer a very short reply. 1.07. What is the ratio of the Female students (as % of total students) in Spain in 1981 to that in 1986?
Keep it short and to the point. 1.01. What is the ratio of the Female students (as % of total students) in Mauritania in 1981 to that in 1987?
Offer a terse response. 0.72. What is the ratio of the Female students (as % of total students) of Seychelles in 1981 to that in 1987?
Provide a short and direct response. 1.07. What is the ratio of the Female students (as % of total students) in Spain in 1981 to that in 1987?
Offer a very short reply. 1.01. What is the ratio of the Female students (as % of total students) in Luxembourg in 1981 to that in 1988?
Offer a terse response. 1. What is the ratio of the Female students (as % of total students) of Mauritania in 1981 to that in 1988?
Your answer should be compact. 0.69. What is the ratio of the Female students (as % of total students) in Seychelles in 1981 to that in 1988?
Your response must be concise. 1.06. What is the ratio of the Female students (as % of total students) of Spain in 1981 to that in 1988?
Offer a terse response. 1.01. What is the ratio of the Female students (as % of total students) of Mauritania in 1982 to that in 1983?
Offer a terse response. 0.92. What is the ratio of the Female students (as % of total students) of Seychelles in 1982 to that in 1983?
Ensure brevity in your answer.  1.01. What is the ratio of the Female students (as % of total students) in Mauritania in 1982 to that in 1984?
Your response must be concise. 0.86. What is the ratio of the Female students (as % of total students) of Seychelles in 1982 to that in 1984?
Give a very brief answer. 1.04. What is the ratio of the Female students (as % of total students) of Mauritania in 1982 to that in 1985?
Offer a very short reply. 0.83. What is the ratio of the Female students (as % of total students) of Seychelles in 1982 to that in 1985?
Provide a succinct answer. 1.02. What is the ratio of the Female students (as % of total students) in Spain in 1982 to that in 1985?
Your answer should be very brief. 1.01. What is the ratio of the Female students (as % of total students) in Luxembourg in 1982 to that in 1986?
Offer a very short reply. 1. What is the ratio of the Female students (as % of total students) of Mauritania in 1982 to that in 1986?
Provide a short and direct response. 0.79. What is the ratio of the Female students (as % of total students) of Seychelles in 1982 to that in 1986?
Give a very brief answer. 1.04. What is the ratio of the Female students (as % of total students) in Spain in 1982 to that in 1986?
Provide a succinct answer. 1.01. What is the ratio of the Female students (as % of total students) of Luxembourg in 1982 to that in 1987?
Your response must be concise. 1.01. What is the ratio of the Female students (as % of total students) of Mauritania in 1982 to that in 1987?
Your response must be concise. 0.76. What is the ratio of the Female students (as % of total students) of Seychelles in 1982 to that in 1987?
Ensure brevity in your answer.  1.05. What is the ratio of the Female students (as % of total students) of Spain in 1982 to that in 1987?
Provide a short and direct response. 1.01. What is the ratio of the Female students (as % of total students) in Luxembourg in 1982 to that in 1988?
Give a very brief answer. 1.01. What is the ratio of the Female students (as % of total students) in Mauritania in 1982 to that in 1988?
Keep it short and to the point. 0.73. What is the ratio of the Female students (as % of total students) in Seychelles in 1982 to that in 1988?
Make the answer very short. 1.04. What is the ratio of the Female students (as % of total students) of Spain in 1982 to that in 1988?
Make the answer very short. 1.01. What is the ratio of the Female students (as % of total students) of Luxembourg in 1983 to that in 1984?
Make the answer very short. 1.01. What is the ratio of the Female students (as % of total students) of Mauritania in 1983 to that in 1984?
Keep it short and to the point. 0.93. What is the ratio of the Female students (as % of total students) of Seychelles in 1983 to that in 1984?
Ensure brevity in your answer.  1.03. What is the ratio of the Female students (as % of total students) in Luxembourg in 1983 to that in 1985?
Provide a succinct answer. 1.01. What is the ratio of the Female students (as % of total students) of Mauritania in 1983 to that in 1985?
Offer a terse response. 0.9. What is the ratio of the Female students (as % of total students) of Seychelles in 1983 to that in 1985?
Give a very brief answer. 1.01. What is the ratio of the Female students (as % of total students) in Spain in 1983 to that in 1985?
Your answer should be compact. 1. What is the ratio of the Female students (as % of total students) in Luxembourg in 1983 to that in 1986?
Provide a short and direct response. 1.01. What is the ratio of the Female students (as % of total students) of Mauritania in 1983 to that in 1986?
Make the answer very short. 0.86. What is the ratio of the Female students (as % of total students) in Seychelles in 1983 to that in 1986?
Make the answer very short. 1.03. What is the ratio of the Female students (as % of total students) of Spain in 1983 to that in 1986?
Make the answer very short. 1.01. What is the ratio of the Female students (as % of total students) in Luxembourg in 1983 to that in 1987?
Ensure brevity in your answer.  1.02. What is the ratio of the Female students (as % of total students) in Mauritania in 1983 to that in 1987?
Your response must be concise. 0.83. What is the ratio of the Female students (as % of total students) in Seychelles in 1983 to that in 1987?
Your response must be concise. 1.04. What is the ratio of the Female students (as % of total students) in Spain in 1983 to that in 1987?
Give a very brief answer. 1. What is the ratio of the Female students (as % of total students) in Luxembourg in 1983 to that in 1988?
Your answer should be very brief. 1.02. What is the ratio of the Female students (as % of total students) of Mauritania in 1983 to that in 1988?
Your response must be concise. 0.8. What is the ratio of the Female students (as % of total students) of Seychelles in 1983 to that in 1988?
Make the answer very short. 1.02. What is the ratio of the Female students (as % of total students) of Spain in 1983 to that in 1988?
Your response must be concise. 1.01. What is the ratio of the Female students (as % of total students) in Luxembourg in 1984 to that in 1985?
Your response must be concise. 1. What is the ratio of the Female students (as % of total students) in Mauritania in 1984 to that in 1985?
Make the answer very short. 0.96. What is the ratio of the Female students (as % of total students) of Seychelles in 1984 to that in 1985?
Offer a terse response. 0.99. What is the ratio of the Female students (as % of total students) of Luxembourg in 1984 to that in 1986?
Keep it short and to the point. 1. What is the ratio of the Female students (as % of total students) in Mauritania in 1984 to that in 1986?
Give a very brief answer. 0.92. What is the ratio of the Female students (as % of total students) of Spain in 1984 to that in 1986?
Give a very brief answer. 1.01. What is the ratio of the Female students (as % of total students) of Luxembourg in 1984 to that in 1987?
Offer a very short reply. 1.01. What is the ratio of the Female students (as % of total students) in Mauritania in 1984 to that in 1987?
Give a very brief answer. 0.89. What is the ratio of the Female students (as % of total students) in Seychelles in 1984 to that in 1987?
Your response must be concise. 1.01. What is the ratio of the Female students (as % of total students) of Spain in 1984 to that in 1987?
Your answer should be very brief. 1. What is the ratio of the Female students (as % of total students) in Luxembourg in 1984 to that in 1988?
Your answer should be very brief. 1.01. What is the ratio of the Female students (as % of total students) of Mauritania in 1984 to that in 1988?
Your response must be concise. 0.85. What is the ratio of the Female students (as % of total students) in Spain in 1984 to that in 1988?
Provide a succinct answer. 1.01. What is the ratio of the Female students (as % of total students) of Mauritania in 1985 to that in 1986?
Make the answer very short. 0.95. What is the ratio of the Female students (as % of total students) of Seychelles in 1985 to that in 1986?
Make the answer very short. 1.02. What is the ratio of the Female students (as % of total students) in Mauritania in 1985 to that in 1987?
Keep it short and to the point. 0.92. What is the ratio of the Female students (as % of total students) in Seychelles in 1985 to that in 1987?
Offer a terse response. 1.02. What is the ratio of the Female students (as % of total students) in Mauritania in 1985 to that in 1988?
Your answer should be compact. 0.88. What is the ratio of the Female students (as % of total students) in Seychelles in 1985 to that in 1988?
Your answer should be compact. 1.01. What is the ratio of the Female students (as % of total students) in Spain in 1985 to that in 1988?
Offer a terse response. 1. What is the ratio of the Female students (as % of total students) of Luxembourg in 1986 to that in 1987?
Ensure brevity in your answer.  1.01. What is the ratio of the Female students (as % of total students) of Mauritania in 1986 to that in 1987?
Offer a very short reply. 0.97. What is the ratio of the Female students (as % of total students) of Seychelles in 1986 to that in 1987?
Provide a succinct answer. 1. What is the ratio of the Female students (as % of total students) of Spain in 1986 to that in 1987?
Make the answer very short. 1. What is the ratio of the Female students (as % of total students) in Luxembourg in 1986 to that in 1988?
Offer a very short reply. 1.01. What is the ratio of the Female students (as % of total students) in Mauritania in 1986 to that in 1988?
Give a very brief answer. 0.93. What is the ratio of the Female students (as % of total students) in Spain in 1986 to that in 1988?
Provide a short and direct response. 1. What is the ratio of the Female students (as % of total students) of Mauritania in 1987 to that in 1988?
Offer a very short reply. 0.96. What is the ratio of the Female students (as % of total students) of Seychelles in 1987 to that in 1988?
Your answer should be compact. 0.99. What is the ratio of the Female students (as % of total students) in Spain in 1987 to that in 1988?
Your response must be concise. 1.01. What is the difference between the highest and the second highest Female students (as % of total students) in Luxembourg?
Give a very brief answer. 0.34. What is the difference between the highest and the second highest Female students (as % of total students) in Mauritania?
Your response must be concise. 1.19. What is the difference between the highest and the second highest Female students (as % of total students) of Spain?
Offer a terse response. 0.02. What is the difference between the highest and the lowest Female students (as % of total students) of Luxembourg?
Make the answer very short. 1.01. What is the difference between the highest and the lowest Female students (as % of total students) of Mauritania?
Keep it short and to the point. 9.32. What is the difference between the highest and the lowest Female students (as % of total students) of Seychelles?
Ensure brevity in your answer.  3.33. What is the difference between the highest and the lowest Female students (as % of total students) of Spain?
Offer a very short reply. 0.56. 